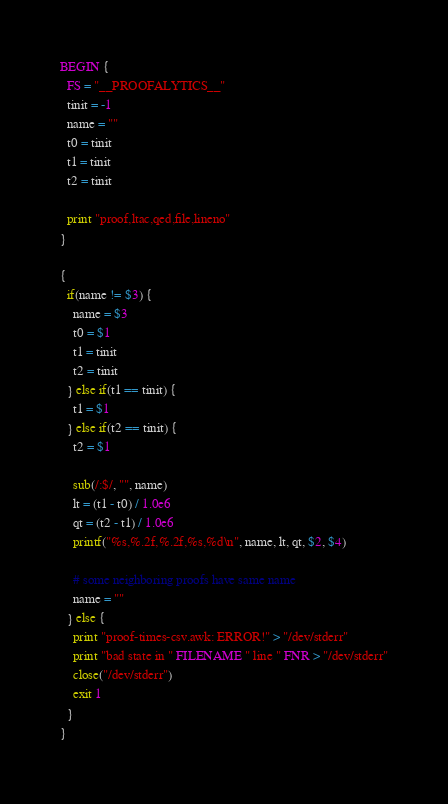Convert code to text. <code><loc_0><loc_0><loc_500><loc_500><_Awk_>BEGIN {
  FS = "__PROOFALYTICS__"
  tinit = -1
  name = ""
  t0 = tinit
  t1 = tinit
  t2 = tinit

  print "proof,ltac,qed,file,lineno"
}

{
  if(name != $3) {
    name = $3
    t0 = $1
    t1 = tinit
    t2 = tinit
  } else if(t1 == tinit) {
    t1 = $1
  } else if(t2 == tinit) {
    t2 = $1

    sub(/:$/, "", name)
    lt = (t1 - t0) / 1.0e6
    qt = (t2 - t1) / 1.0e6
    printf("%s,%.2f,%.2f,%s,%d\n", name, lt, qt, $2, $4)

    # some neighboring proofs have same name
    name = ""
  } else {
    print "proof-times-csv.awk: ERROR!" > "/dev/stderr"
    print "bad state in " FILENAME " line " FNR > "/dev/stderr"
    close("/dev/stderr")
    exit 1
  }
}
</code> 